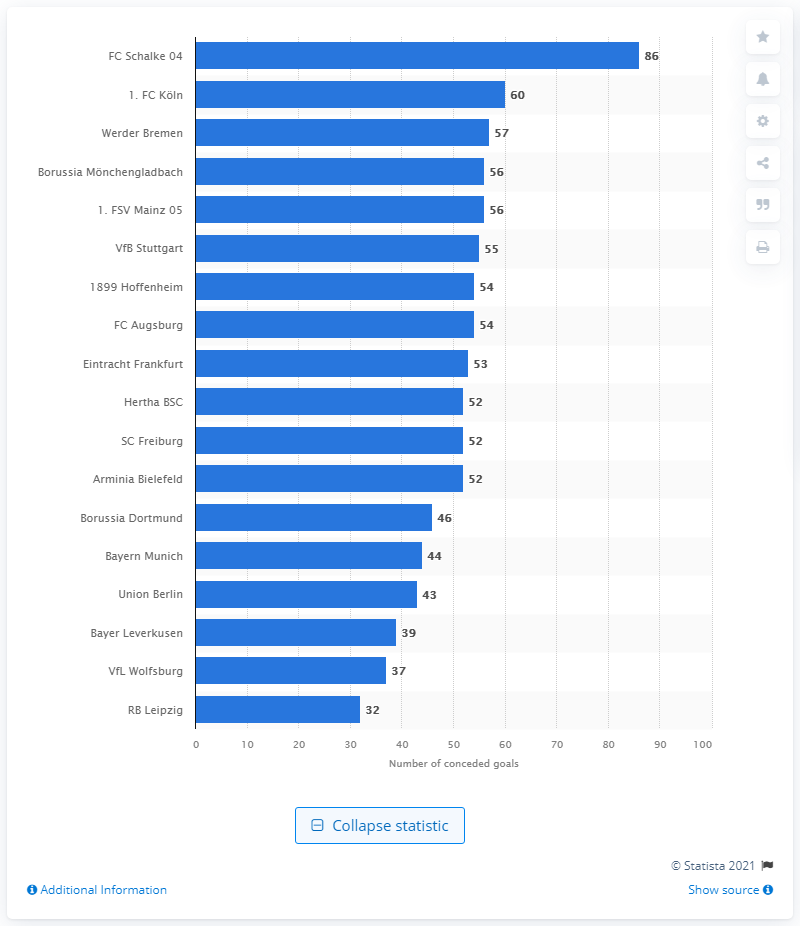Give some essential details in this illustration. I declare that Schalke 04 had 86 conceded goals. FC Kln conceded a total of 60 goals. 